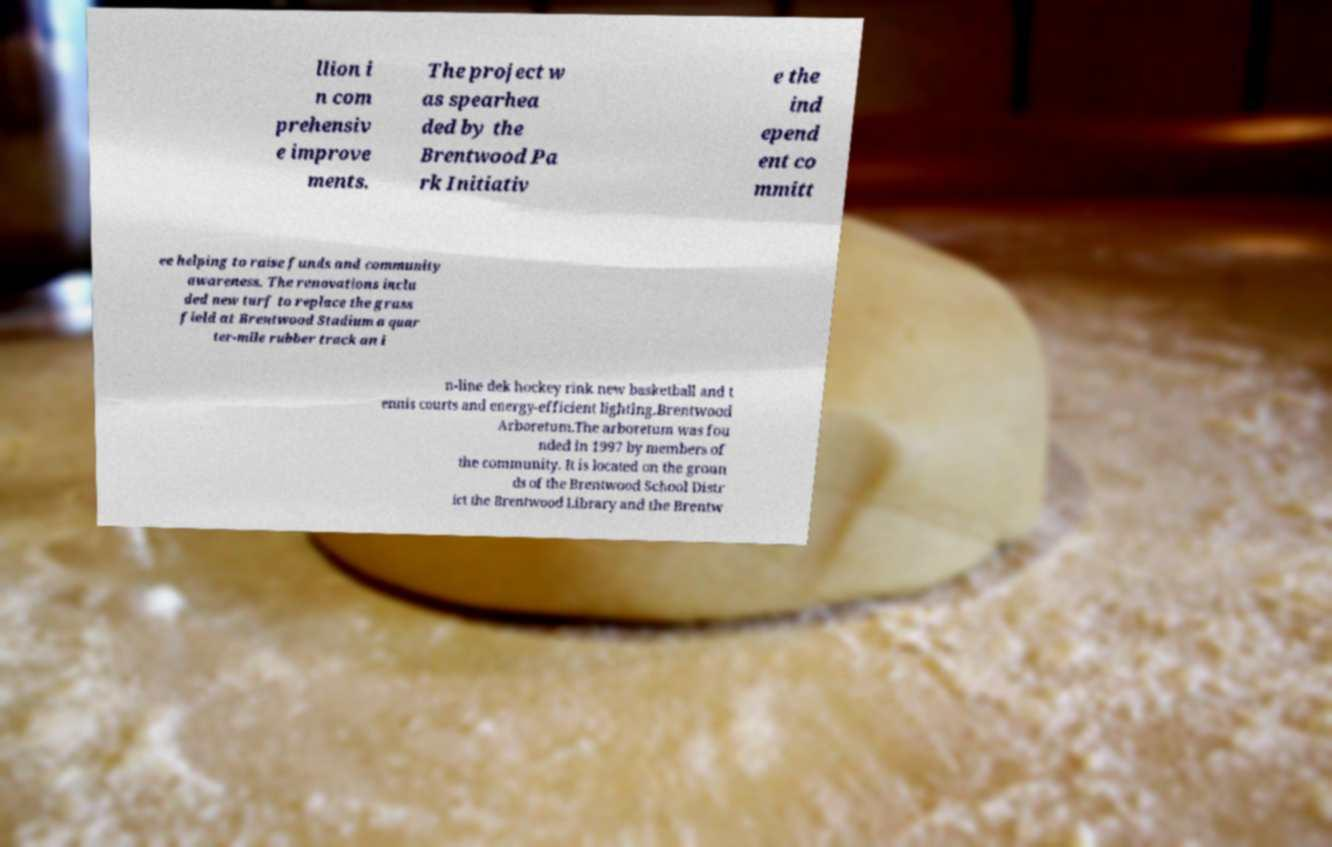I need the written content from this picture converted into text. Can you do that? llion i n com prehensiv e improve ments. The project w as spearhea ded by the Brentwood Pa rk Initiativ e the ind epend ent co mmitt ee helping to raise funds and community awareness. The renovations inclu ded new turf to replace the grass field at Brentwood Stadium a quar ter-mile rubber track an i n-line dek hockey rink new basketball and t ennis courts and energy-efficient lighting.Brentwood Arboretum.The arboretum was fou nded in 1997 by members of the community. It is located on the groun ds of the Brentwood School Distr ict the Brentwood Library and the Brentw 